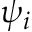Convert formula to latex. <formula><loc_0><loc_0><loc_500><loc_500>\psi _ { i }</formula> 